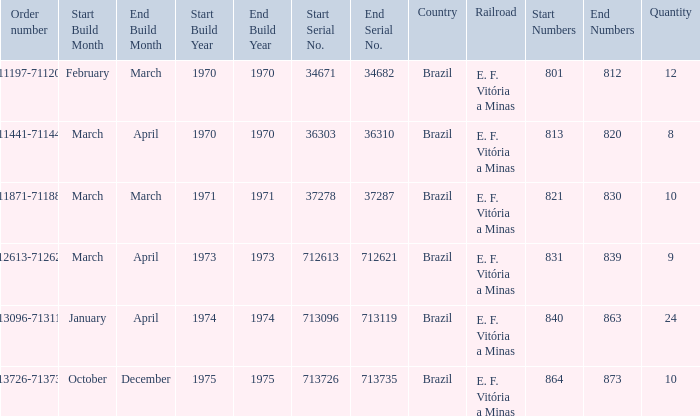Which country has the serial numbers 713096-713119? Brazil. 